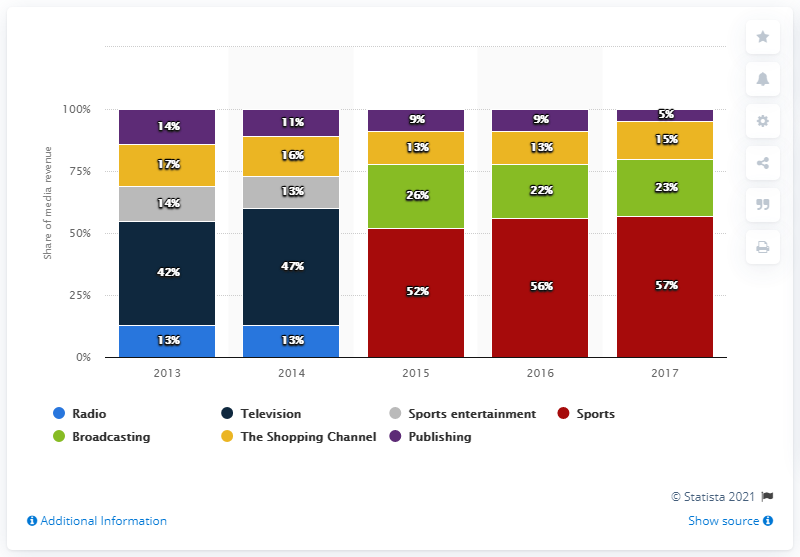Give some essential details in this illustration. The colored bar with the maximum value is red. The mode of The Shopping Channel minus that of publishing gives a result of 3. 